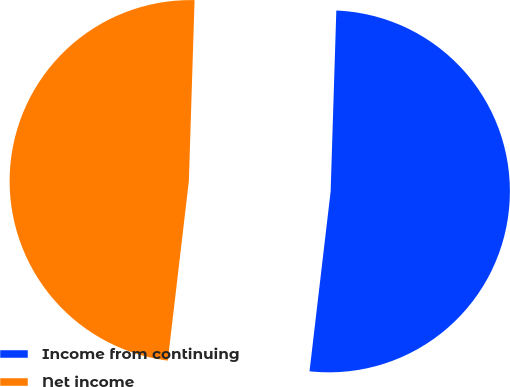Convert chart. <chart><loc_0><loc_0><loc_500><loc_500><pie_chart><fcel>Income from continuing<fcel>Net income<nl><fcel>51.36%<fcel>48.64%<nl></chart> 